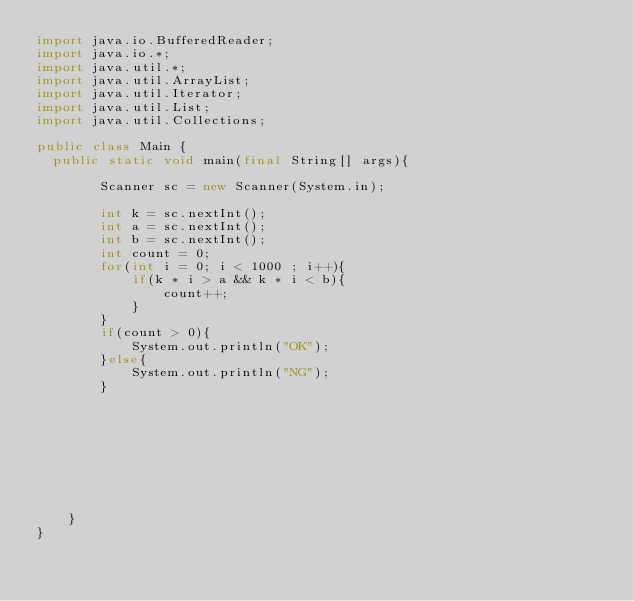<code> <loc_0><loc_0><loc_500><loc_500><_Java_>import java.io.BufferedReader;
import java.io.*;
import java.util.*;
import java.util.ArrayList;
import java.util.Iterator;
import java.util.List;
import java.util.Collections;

public class Main {
	public static void main(final String[] args){
    
        Scanner sc = new Scanner(System.in);

        int k = sc.nextInt();
        int a = sc.nextInt();
        int b = sc.nextInt();
        int count = 0;
        for(int i = 0; i < 1000 ; i++){
            if(k * i > a && k * i < b){
                count++;
            }
        }
        if(count > 0){
            System.out.println("OK");
        }else{
            System.out.println("NG");
        }

        
        






    }
}</code> 